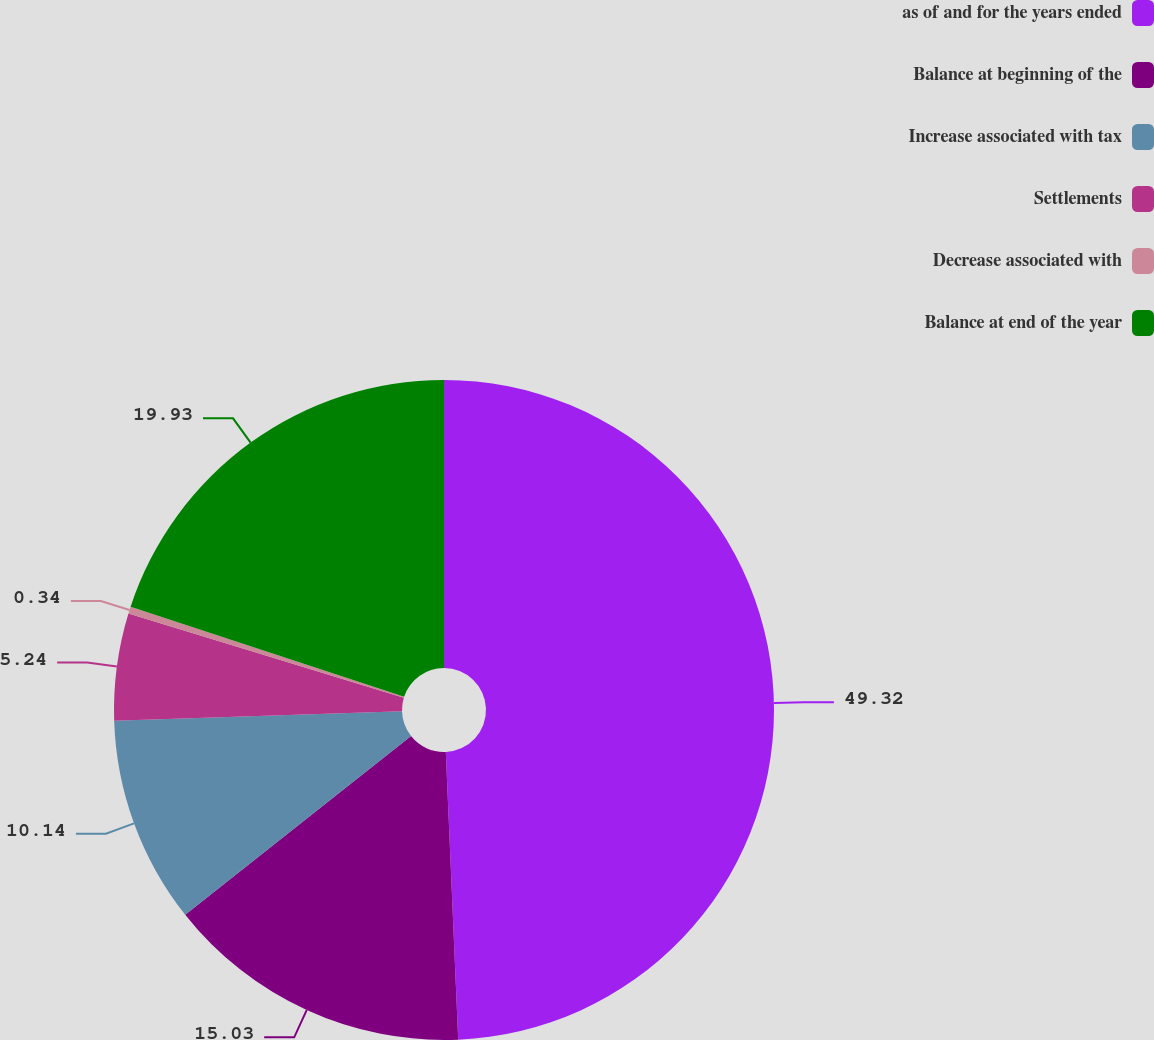Convert chart. <chart><loc_0><loc_0><loc_500><loc_500><pie_chart><fcel>as of and for the years ended<fcel>Balance at beginning of the<fcel>Increase associated with tax<fcel>Settlements<fcel>Decrease associated with<fcel>Balance at end of the year<nl><fcel>49.31%<fcel>15.03%<fcel>10.14%<fcel>5.24%<fcel>0.34%<fcel>19.93%<nl></chart> 